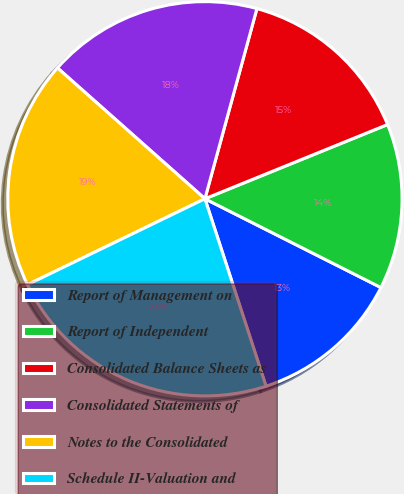<chart> <loc_0><loc_0><loc_500><loc_500><pie_chart><fcel>Report of Management on<fcel>Report of Independent<fcel>Consolidated Balance Sheets as<fcel>Consolidated Statements of<fcel>Notes to the Consolidated<fcel>Schedule II-Valuation and<nl><fcel>12.55%<fcel>13.58%<fcel>14.61%<fcel>17.7%<fcel>18.73%<fcel>22.84%<nl></chart> 